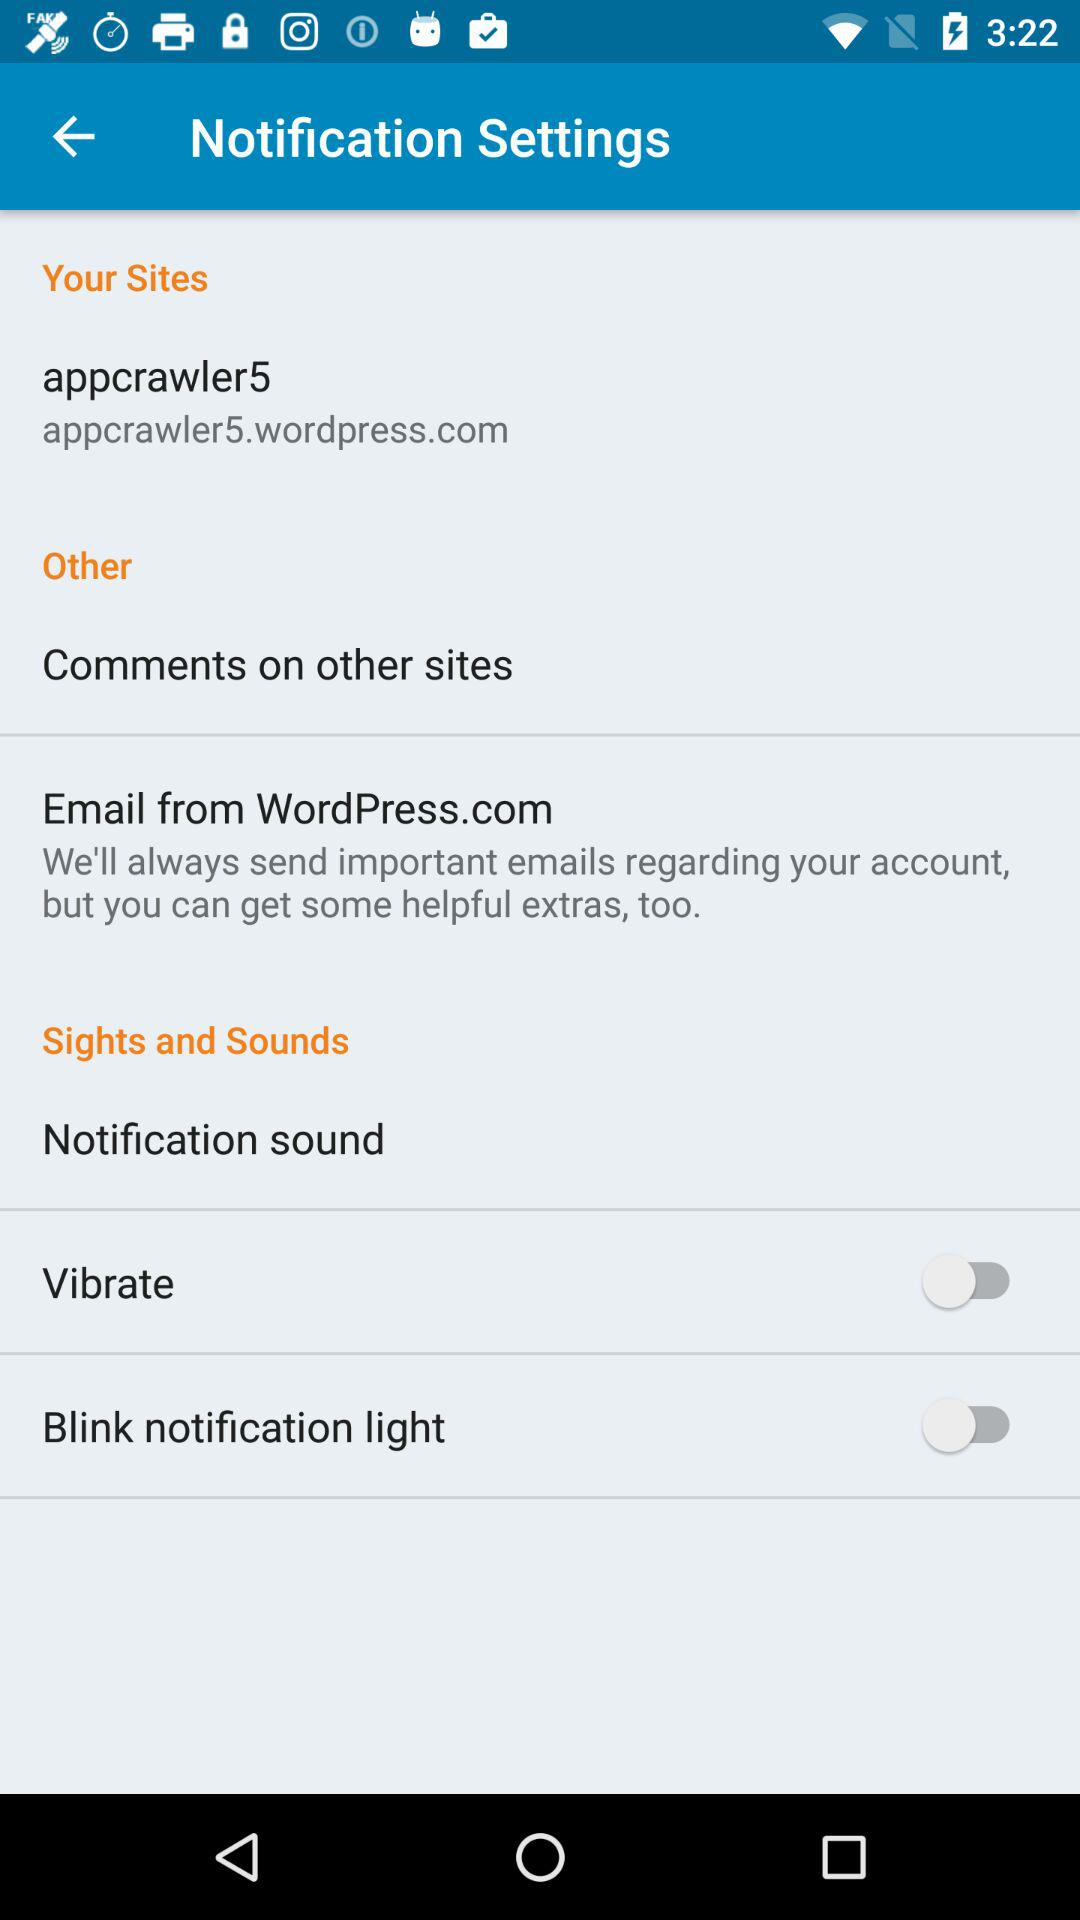What is the email address given?
When the provided information is insufficient, respond with <no answer>. <no answer> 